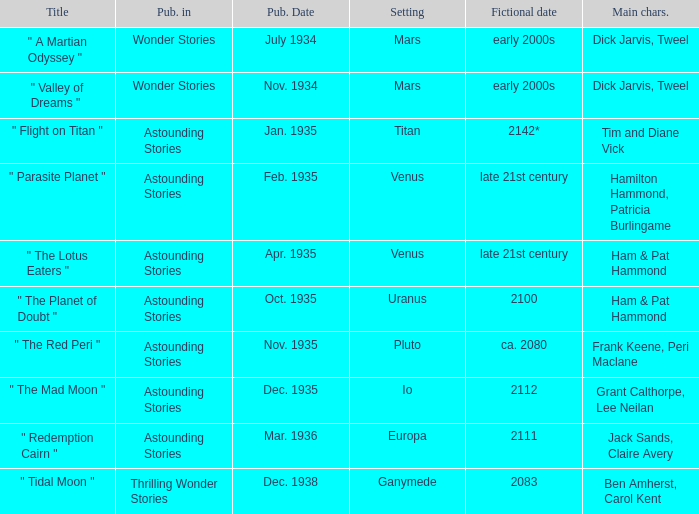Name what was published in july 1934 with a setting of mars Wonder Stories. 